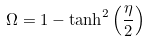Convert formula to latex. <formula><loc_0><loc_0><loc_500><loc_500>\Omega = 1 - \tanh ^ { 2 } \left ( \frac { \eta } { 2 } \right )</formula> 